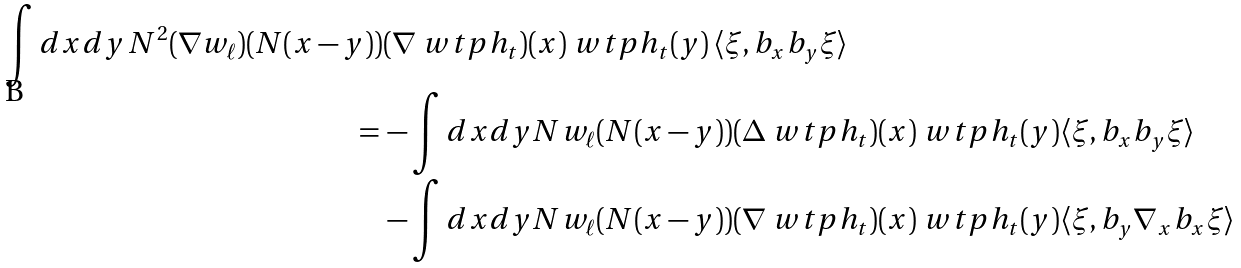<formula> <loc_0><loc_0><loc_500><loc_500>\int d x d y \, N ^ { 2 } ( \nabla w _ { \ell } ) ( N ( x - y ) ) & ( \nabla \ w t p h _ { t } ) ( x ) \ w t p h _ { t } ( y ) \, \langle \xi , b _ { x } b _ { y } \xi \rangle \\ = \, & - \int d x d y N w _ { \ell } ( N ( x - y ) ) ( \Delta \ w t p h _ { t } ) ( x ) \ w t p h _ { t } ( y ) \langle \xi , b _ { x } b _ { y } \xi \rangle \\ & - \int d x d y N w _ { \ell } ( N ( x - y ) ) ( \nabla \ w t p h _ { t } ) ( x ) \ w t p h _ { t } ( y ) \langle \xi , b _ { y } \nabla _ { x } b _ { x } \xi \rangle</formula> 